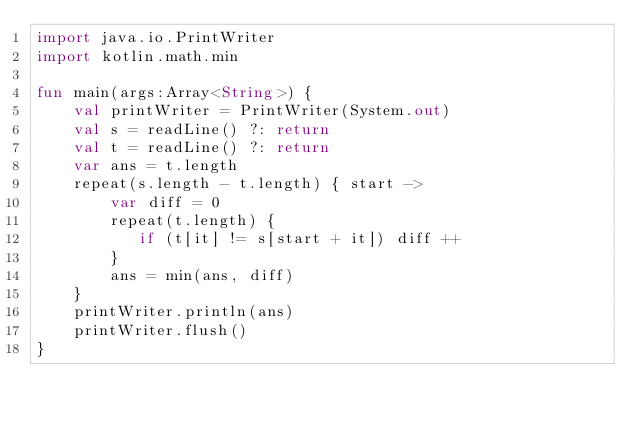<code> <loc_0><loc_0><loc_500><loc_500><_Kotlin_>import java.io.PrintWriter
import kotlin.math.min

fun main(args:Array<String>) {
    val printWriter = PrintWriter(System.out)
    val s = readLine() ?: return
    val t = readLine() ?: return
    var ans = t.length
    repeat(s.length - t.length) { start ->
        var diff = 0
        repeat(t.length) {
           if (t[it] != s[start + it]) diff ++
        }
        ans = min(ans, diff)
    }
    printWriter.println(ans)
    printWriter.flush()
}</code> 